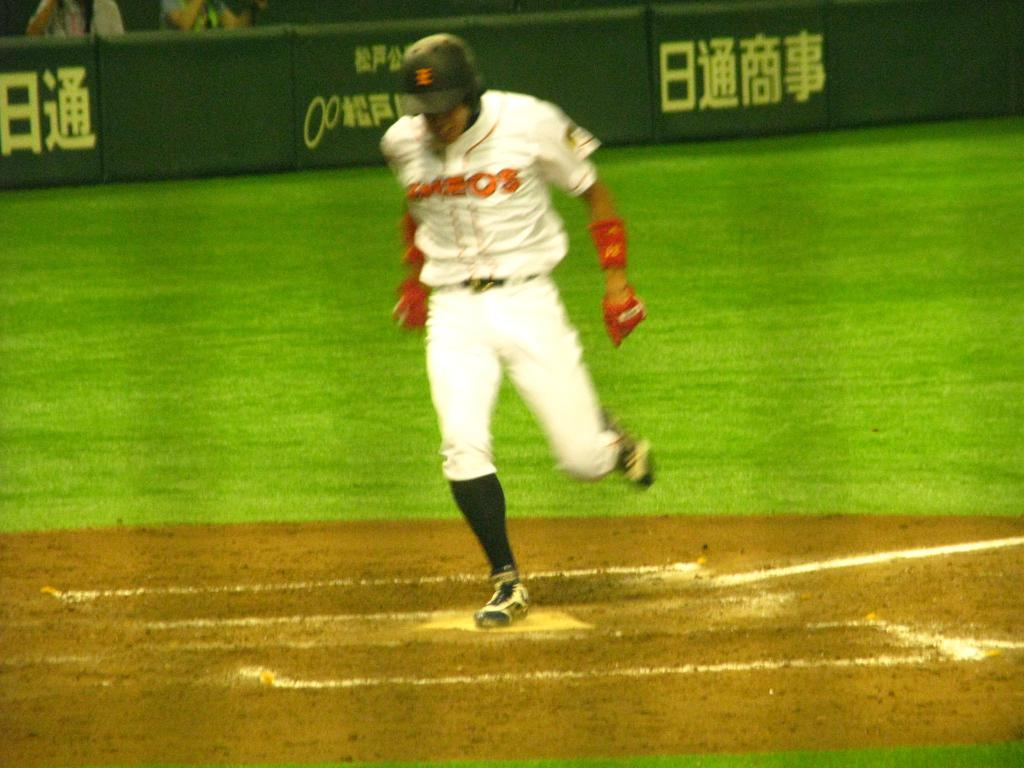<image>
Give a short and clear explanation of the subsequent image. A baseball player gets to a base, the barrier to the stands covered in Asian letters. 